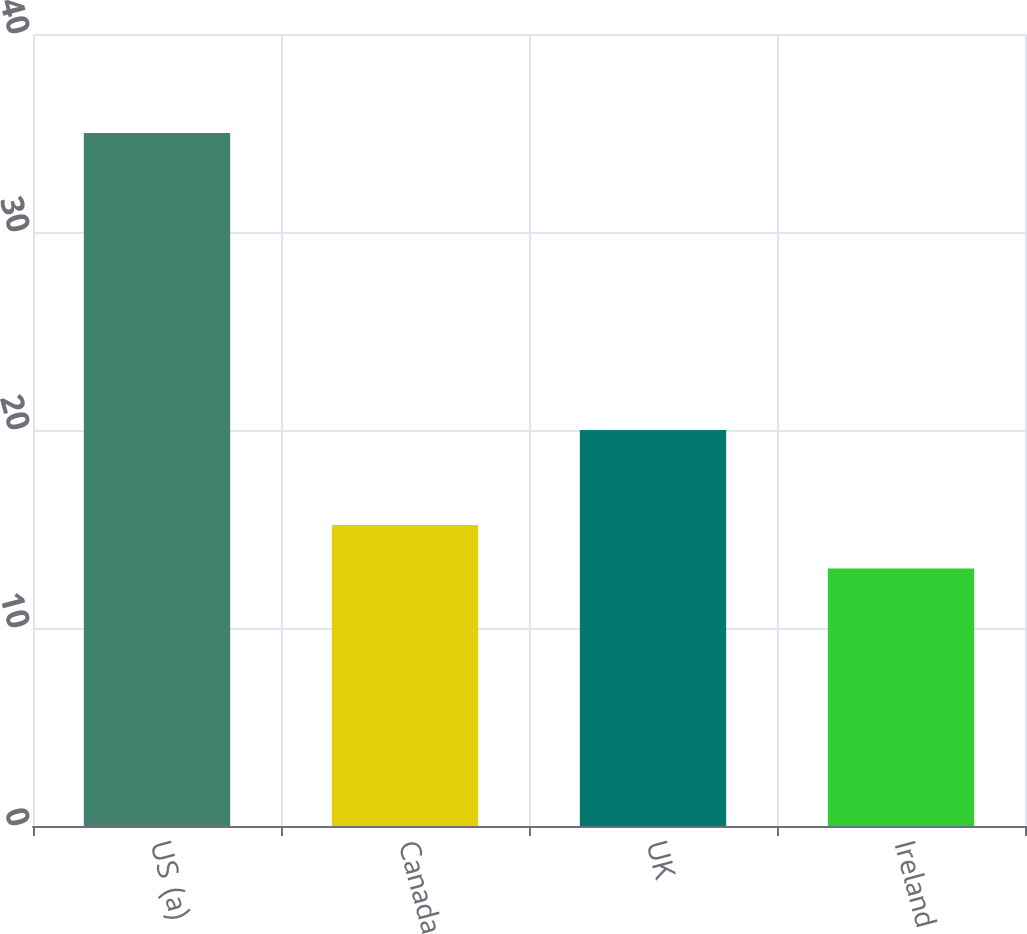<chart> <loc_0><loc_0><loc_500><loc_500><bar_chart><fcel>US (a)<fcel>Canada<fcel>UK<fcel>Ireland<nl><fcel>35<fcel>15.2<fcel>20<fcel>13<nl></chart> 